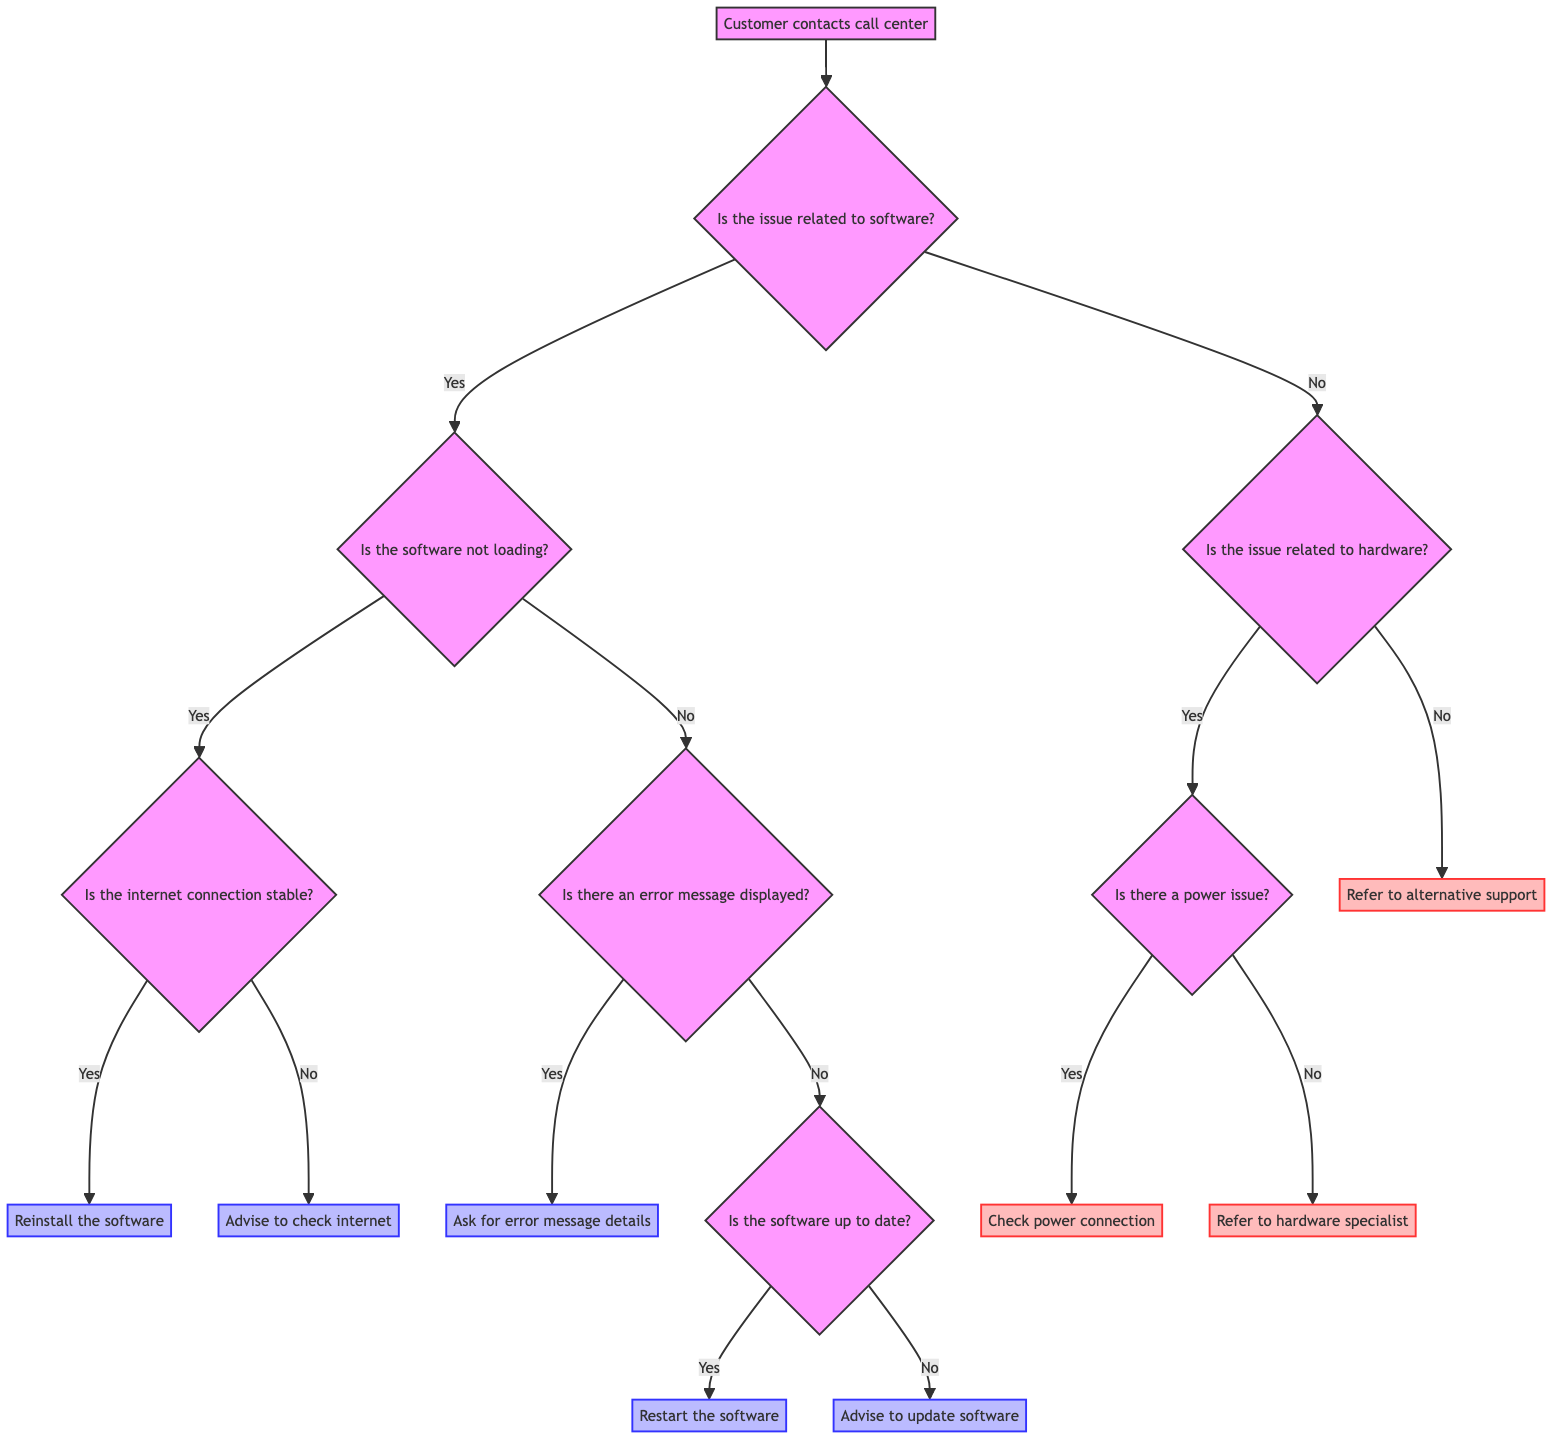What is the first question in this decision tree? The decision tree starts with the question "Is the issue related to software?" which is the first node directly connected to the starting point "Customer contacts call center."
Answer: Is the issue related to software? How many main branches are there from the initial question? The initial question branches into two main paths: one for software-related issues and another for hardware-related issues, creating a total of two branches.
Answer: 2 What action is suggested if there is an error message displayed? If an error message is displayed, the next step is to "Ask for error message details" which helps gather necessary information for troubleshooting.
Answer: Ask for error message details What happens if the software is up to date? If the software is up to date, the flow directs to "Restart the software and see if the issue is resolved," indicating a troubleshooting step to potentially fix the problem.
Answer: Restart the software If the internet connection is not stable, what advice is given? The diagram indicates that if the internet connection is not stable, the advisor should "Advise the customer to check their internet connection" to ensure that connectivity issues are resolved before addressing software problems.
Answer: Advise to check internet Which group does the node "Refer to hardware specialist" belong to? The node "Refer to hardware specialist" is classified under hardware-related issues, specifically when the problem is not related to power. It provides a referral for further assistance, indicating it is the path taken when hardware expertise is needed.
Answer: hardware What step is taken if the software is not loading and the internet connection is stable? If the software is not loading and the internet connection is confirmed stable, the resolution path directs to "Reinstall the software and check if the issue persists," indicating an attempt to reestablish functionality through reinstallation.
Answer: Reinstall the software What is the outcome if there is no power issue detected? If the assessment shows that there is no power issue, the guidance directs to "Refer to hardware specialist," thereby indicating the continuation of the troubleshooting process towards specialized support for hardware-related problems.
Answer: Refer to hardware specialist What must be done after collecting error message details? After collecting error message details, the action indicated is to "Log details and escalate if needed," which suggests that if the issue is serious, it may require further review or action from a higher level of technical support.
Answer: Log details and escalate if needed 